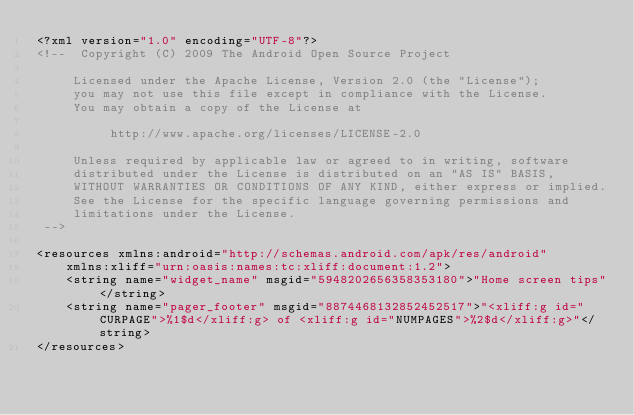<code> <loc_0><loc_0><loc_500><loc_500><_XML_><?xml version="1.0" encoding="UTF-8"?>
<!--  Copyright (C) 2009 The Android Open Source Project

     Licensed under the Apache License, Version 2.0 (the "License");
     you may not use this file except in compliance with the License.
     You may obtain a copy of the License at

          http://www.apache.org/licenses/LICENSE-2.0

     Unless required by applicable law or agreed to in writing, software
     distributed under the License is distributed on an "AS IS" BASIS,
     WITHOUT WARRANTIES OR CONDITIONS OF ANY KIND, either express or implied.
     See the License for the specific language governing permissions and
     limitations under the License.
 -->

<resources xmlns:android="http://schemas.android.com/apk/res/android"
    xmlns:xliff="urn:oasis:names:tc:xliff:document:1.2">
    <string name="widget_name" msgid="5948202656358353180">"Home screen tips"</string>
    <string name="pager_footer" msgid="8874468132852452517">"<xliff:g id="CURPAGE">%1$d</xliff:g> of <xliff:g id="NUMPAGES">%2$d</xliff:g>"</string>
</resources>
</code> 